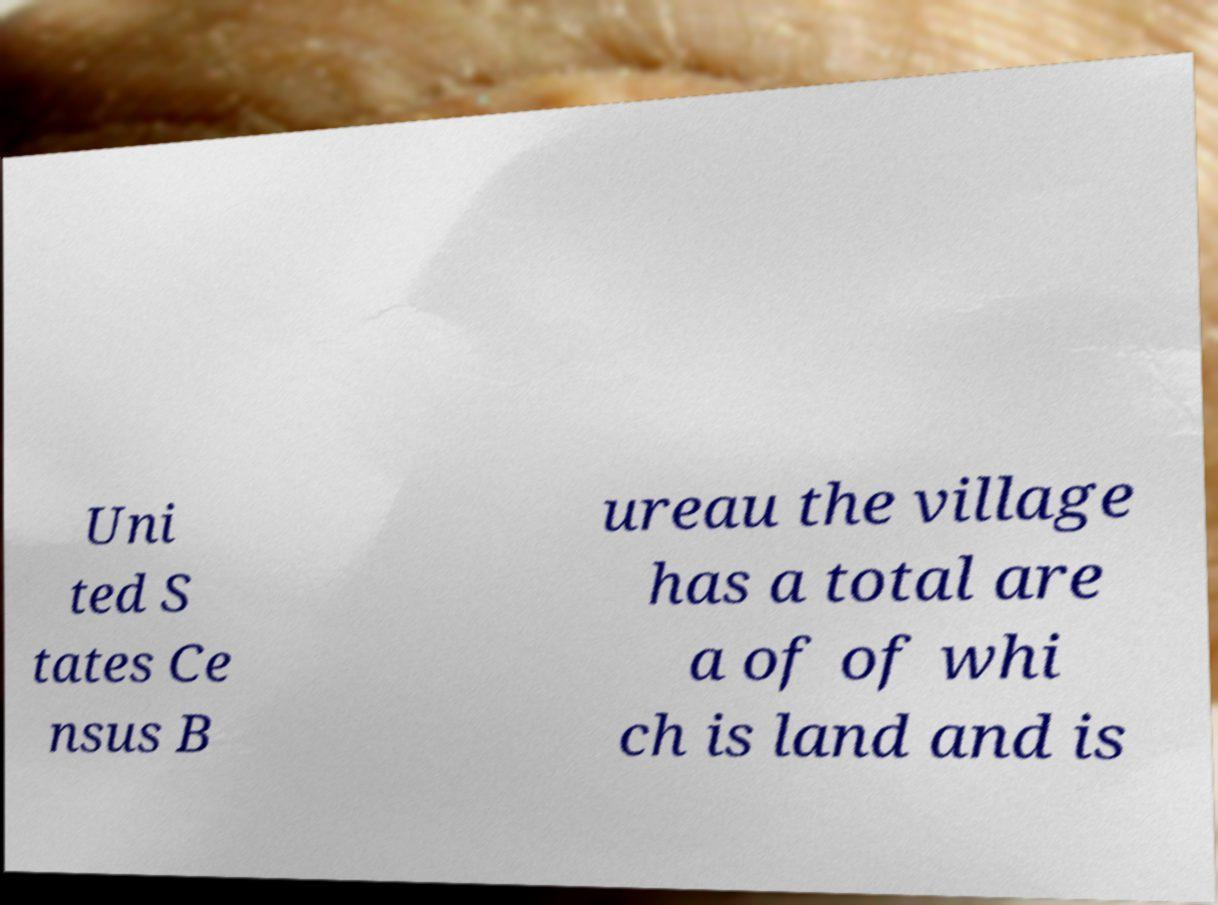Can you read and provide the text displayed in the image?This photo seems to have some interesting text. Can you extract and type it out for me? Uni ted S tates Ce nsus B ureau the village has a total are a of of whi ch is land and is 